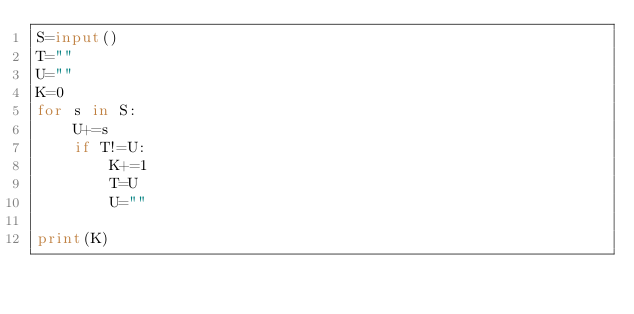Convert code to text. <code><loc_0><loc_0><loc_500><loc_500><_Python_>S=input()
T=""
U=""
K=0
for s in S:
    U+=s
    if T!=U:
        K+=1
        T=U
        U=""

print(K)
</code> 